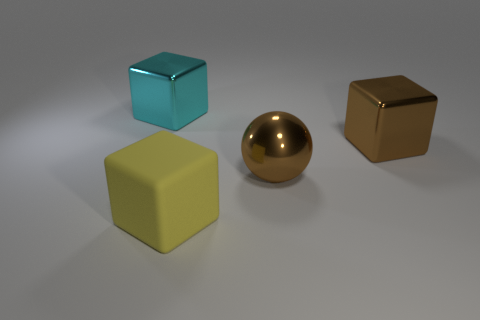Is there any other thing that has the same material as the yellow thing?
Your answer should be compact. No. How many things are either objects that are in front of the big brown metallic cube or brown cylinders?
Give a very brief answer. 2. Are there any other things that have the same size as the ball?
Your answer should be very brief. Yes. What is the material of the cube that is behind the big block on the right side of the big yellow matte cube?
Keep it short and to the point. Metal. Are there the same number of big objects behind the large brown ball and yellow rubber cubes behind the cyan metallic thing?
Your response must be concise. No. What number of objects are either metallic objects that are in front of the brown cube or shiny spheres that are right of the matte thing?
Offer a terse response. 1. There is a object that is in front of the big cyan cube and behind the large brown metallic sphere; what material is it?
Give a very brief answer. Metal. What size is the brown object in front of the shiny cube that is in front of the big object on the left side of the matte object?
Provide a short and direct response. Large. Are there more blue objects than yellow matte objects?
Your answer should be very brief. No. Is the thing that is right of the big brown shiny sphere made of the same material as the big yellow object?
Your answer should be very brief. No. 